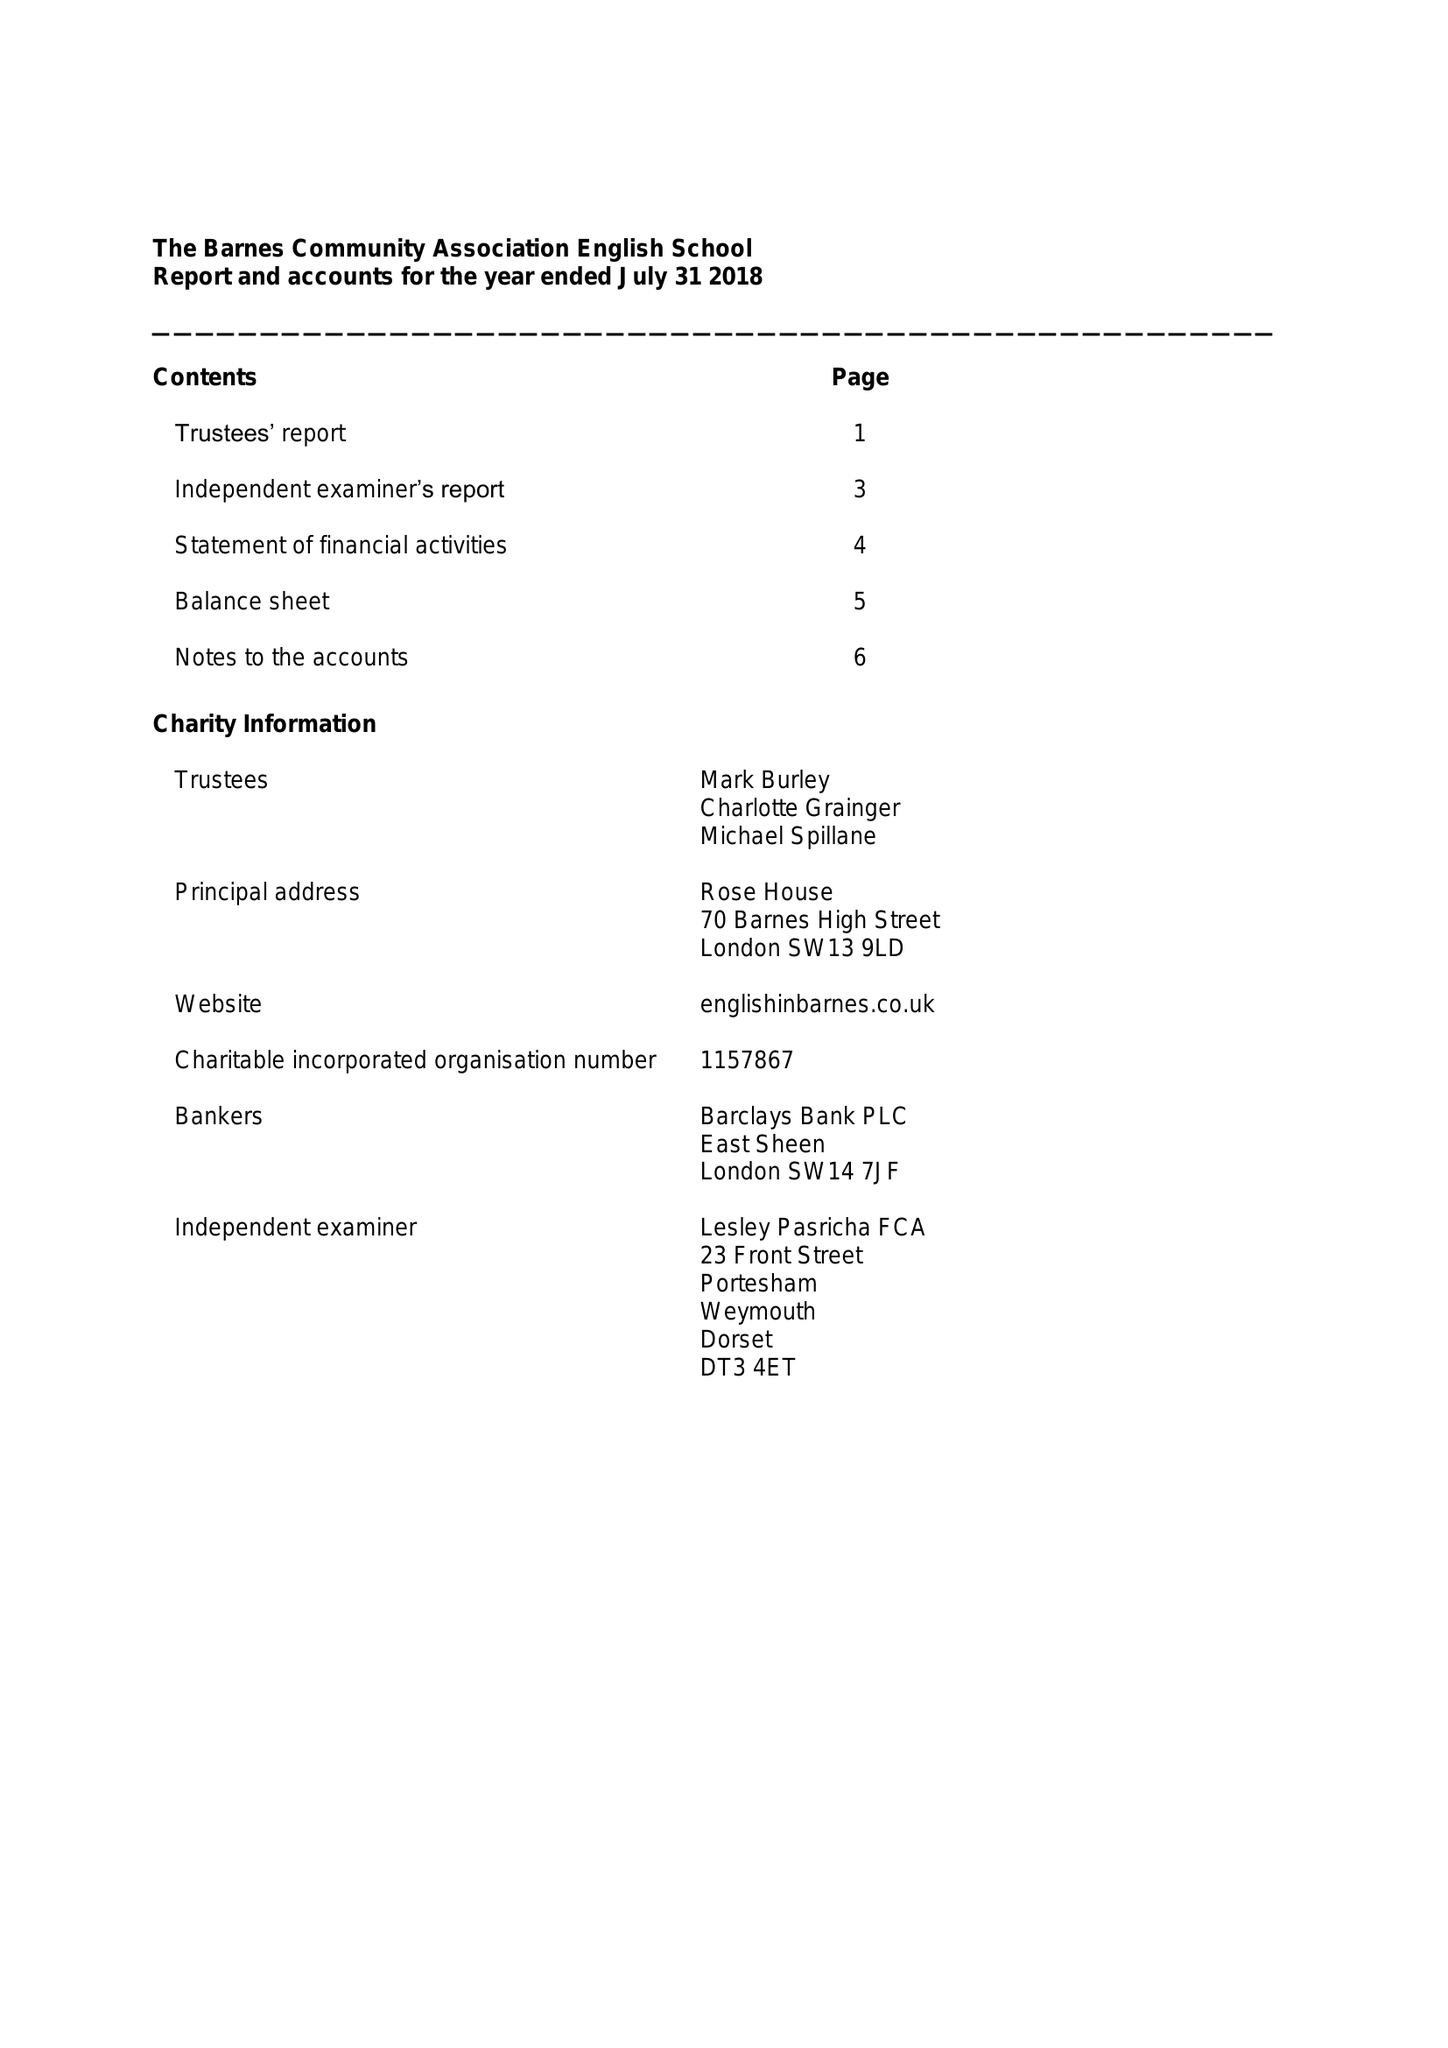What is the value for the address__street_line?
Answer the question using a single word or phrase. 70 BARNES HIGH STREET 